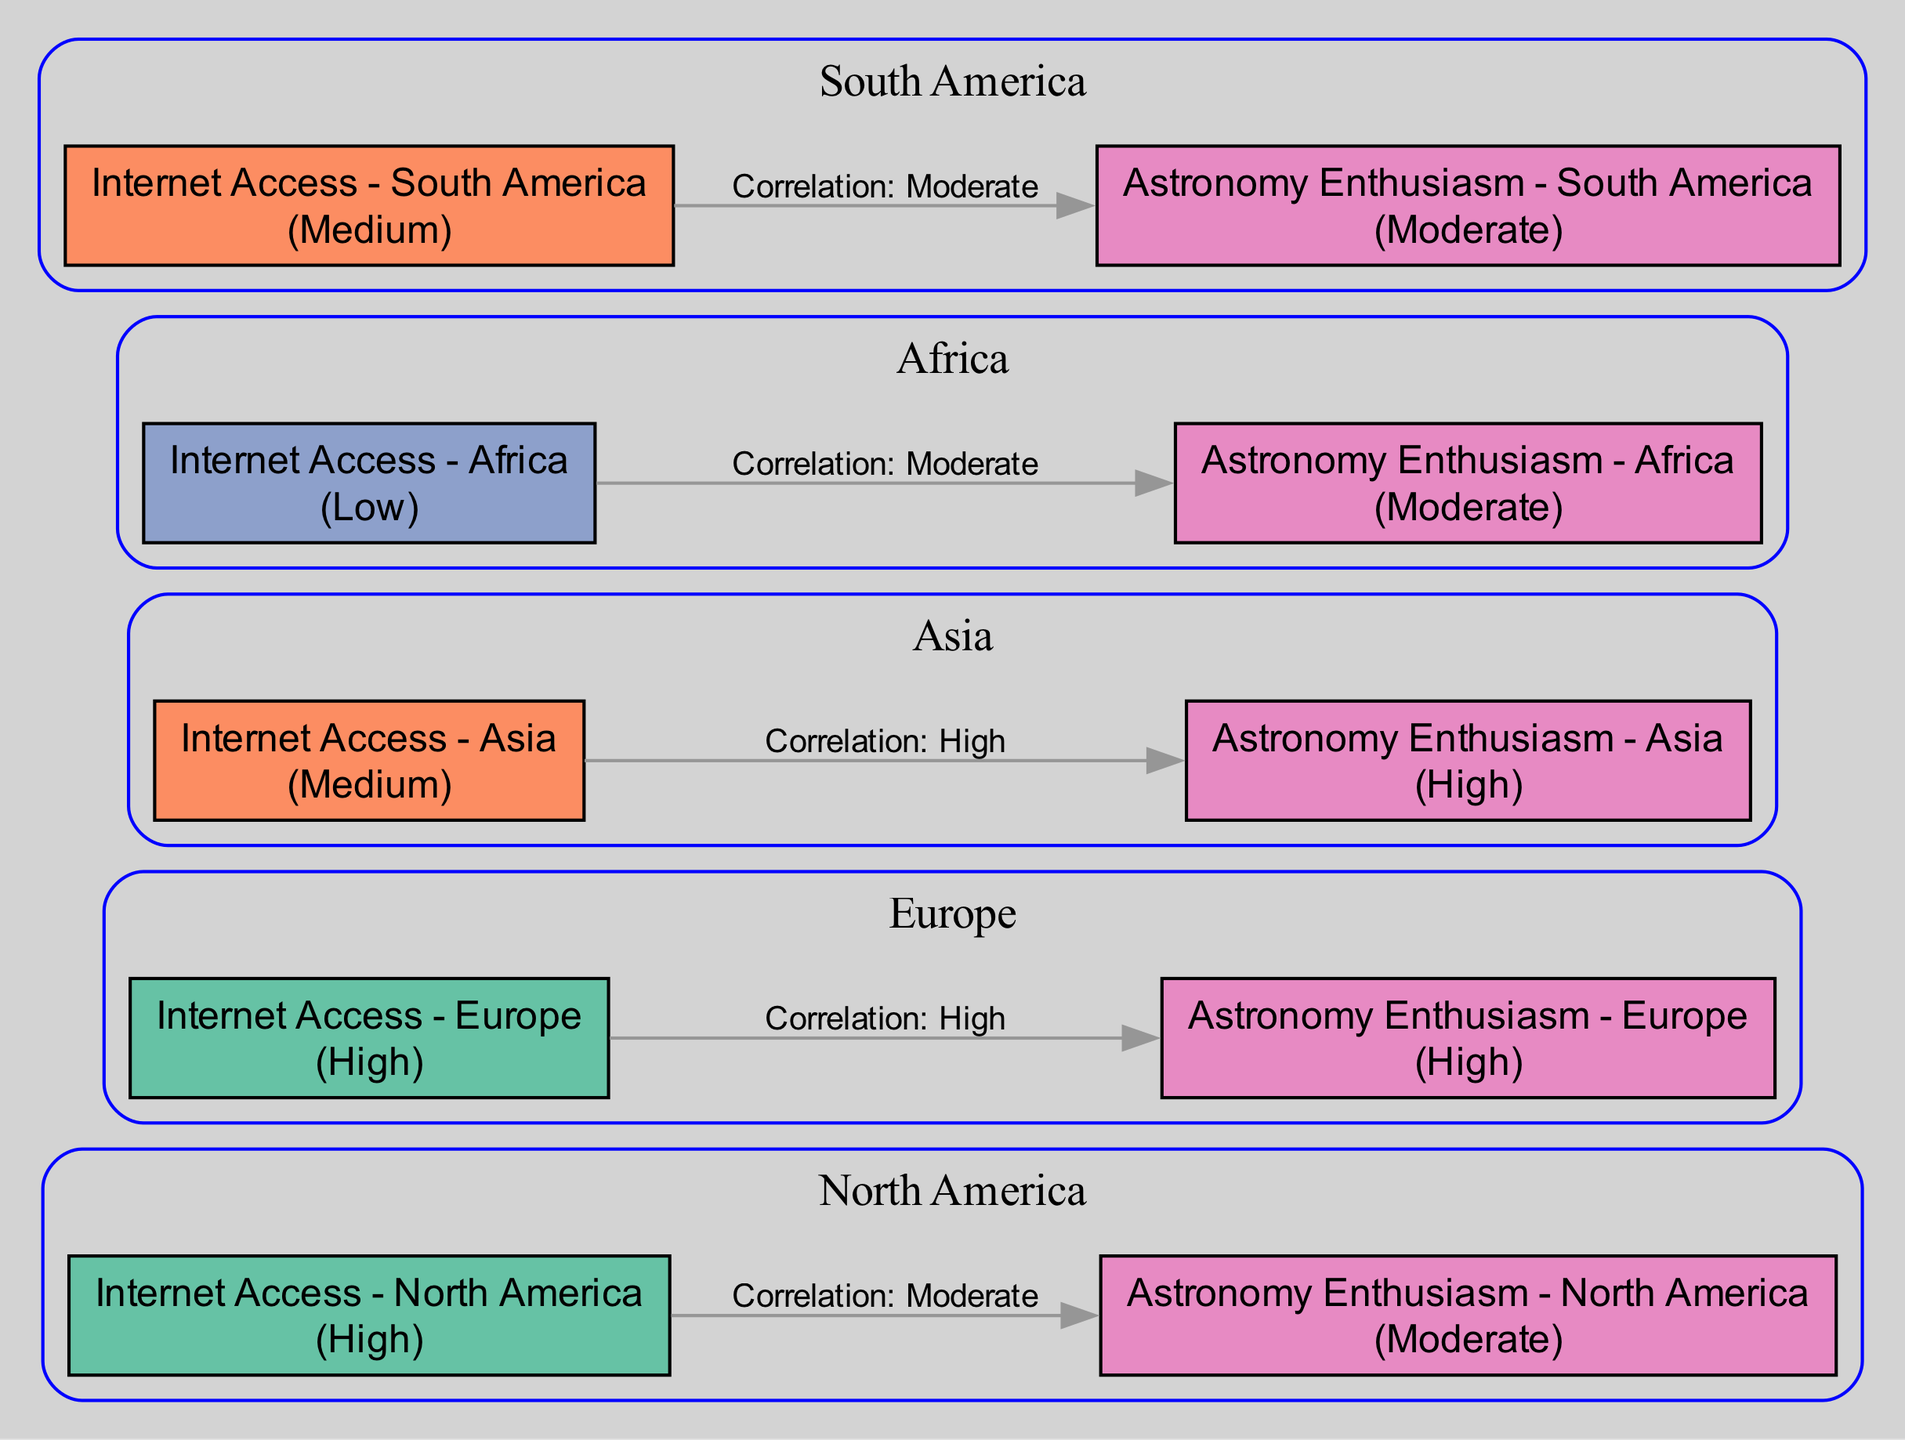What is the internet access level in North America? The diagram indicates that the internet access level in North America is described as "High." This information is found in the node labeled "Internet Access - North America."
Answer: High What is the astronomy enthusiasm level in Europe? According to the diagram, the astronomy enthusiasm level in Europe is "High." This can be identified in the node labeled "Astronomy Enthusiasm - Europe."
Answer: High How many edges connect internet access and astronomy enthusiasm nodes? The diagram shows a total of five edges connecting internet access nodes to their corresponding astronomy enthusiasm nodes—one for each region.
Answer: Five What is the correlation type between internet access and astronomy enthusiasm in Asia? The diagram specifies a "High" correlation between internet access and astronomy enthusiasm for the region of Asia, as indicated by the edge connecting the respective nodes.
Answer: High Which region has a moderate level of astronomy enthusiasm alongside high internet access? The diagram illustrates that North America has a moderate level of astronomy enthusiasm while also having high levels of internet access. This information can be obtained by examining both nodes and their correlation edge.
Answer: North America Which region has the lowest internet access level? The information in the diagram reveals that Africa has the lowest internet access level, categorized as "Low" in the corresponding node labeled "Internet Access - Africa."
Answer: Low What common correlation type do South America and Africa share regarding astronomy enthusiasm? The diagram shows that both South America and Africa have a "Moderate" correlation with astronomy enthusiasm when considered against their internet access levels, as indicated by the edges connecting their respective nodes.
Answer: Moderate How does astronomy enthusiasm in Asia compare with that in Europe? The diagram indicates that while Asia has "High" astronomy enthusiasm, Europe also shares a "High" enthusiasm level, suggesting that both regions exhibit the same level of enthusiasm for astronomy.
Answer: Same Level What is the difference in internet access levels between Europe and Africa? In the diagram, the level of internet access in Europe is described as "High," whereas in Africa, it is described as "Low." This results in a clear difference of two levels in internet access.
Answer: Two Levels 